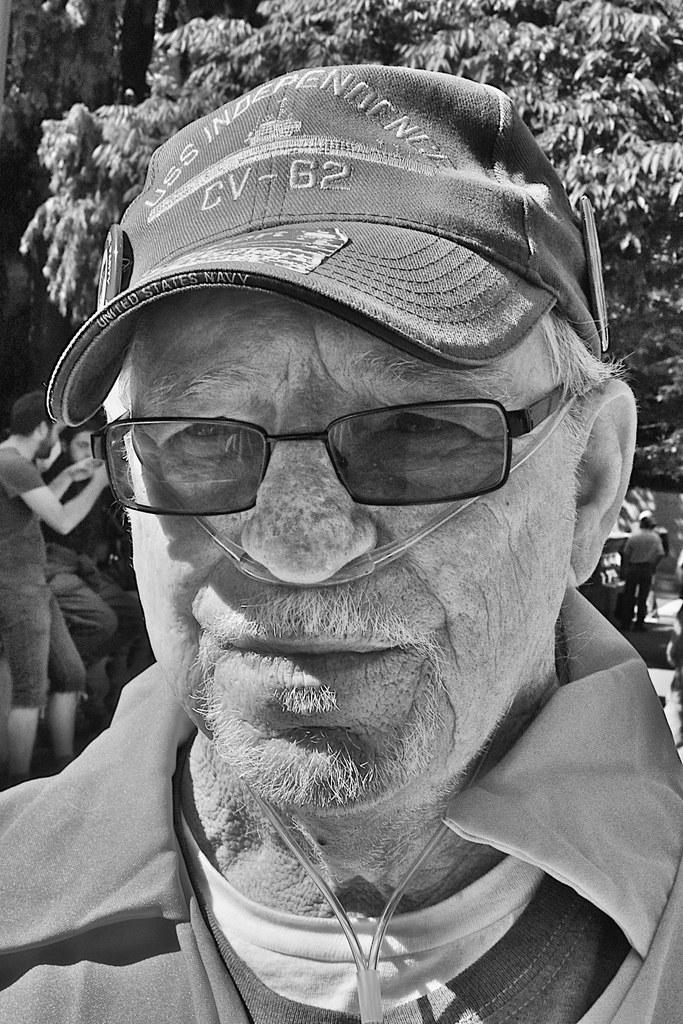What is the color scheme of the image? The image is black and white. Can you describe the person in the image? The person in the image is wearing glasses and a cap. What can be seen in the background of the image? There are trees and people visible in the background of the image. What type of scarf is the person wearing in the image? There is no scarf visible in the image; the person is wearing glasses and a cap. How does the person in the image respond to the coughing sound in the background? There is no coughing sound present in the image, so it is not possible to determine how the person would respond. 